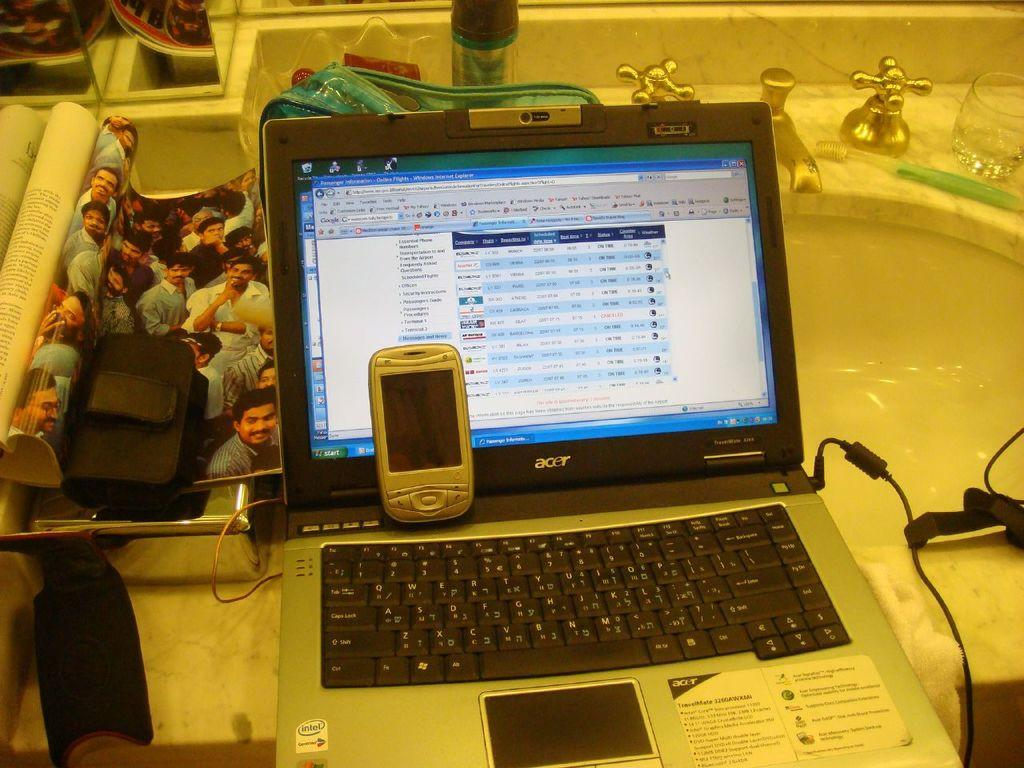<image>
Summarize the visual content of the image. An Acer laptop is open and sitting on a bathroom sink. 